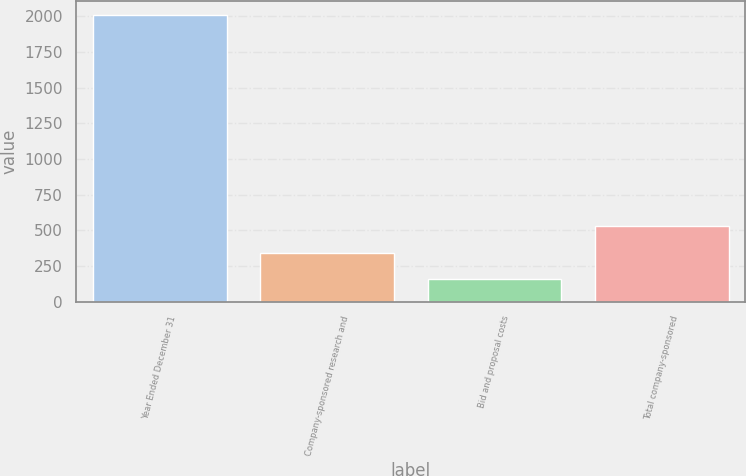Convert chart to OTSL. <chart><loc_0><loc_0><loc_500><loc_500><bar_chart><fcel>Year Ended December 31<fcel>Company-sponsored research and<fcel>Bid and proposal costs<fcel>Total company-sponsored<nl><fcel>2008<fcel>342.1<fcel>157<fcel>527.2<nl></chart> 